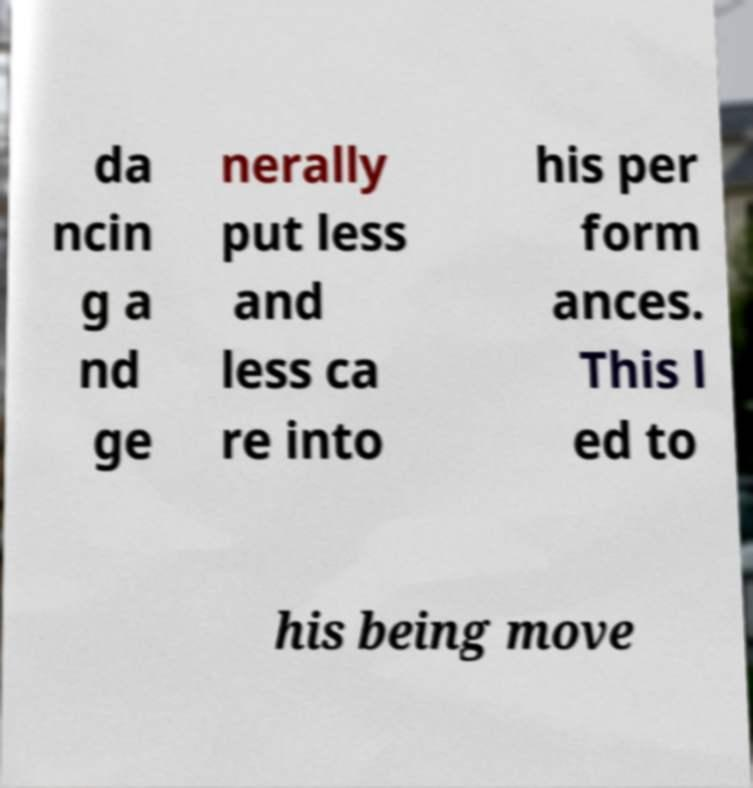Please identify and transcribe the text found in this image. da ncin g a nd ge nerally put less and less ca re into his per form ances. This l ed to his being move 